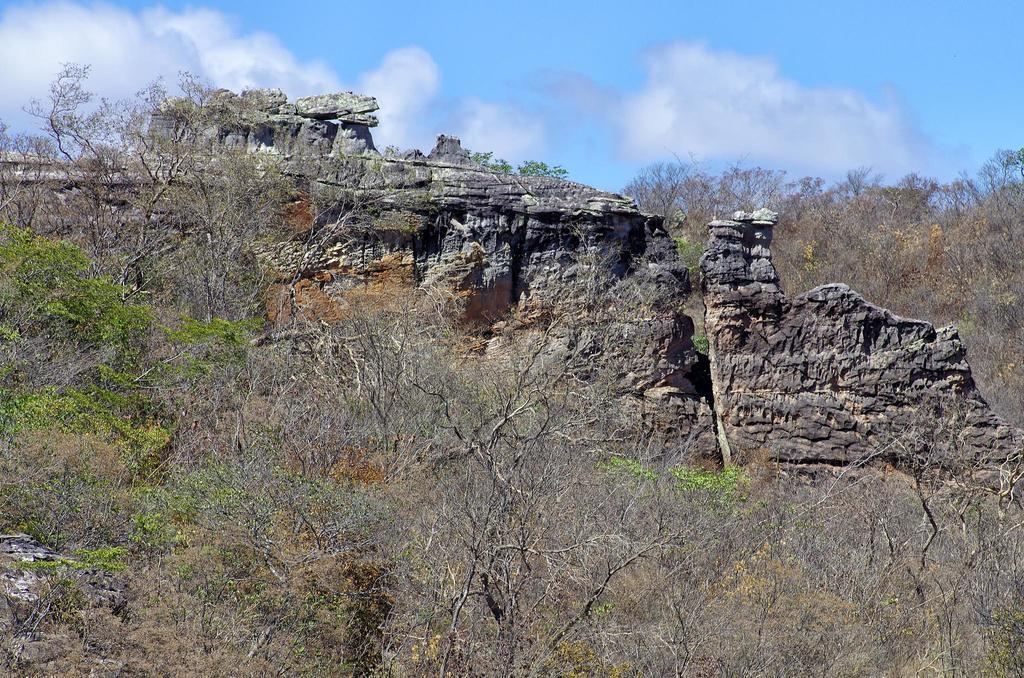What type of natural elements can be seen in the image? There are trees and rocks in the image. What is visible in the background of the image? The sky is visible in the background of the image. What can be observed in the sky? Clouds are present in the sky. How many oranges are hanging from the trees in the image? There are no oranges present in the image; it features trees and rocks. What is the color of the wristwatch visible on the rocks? There is no wristwatch visible in the image. 